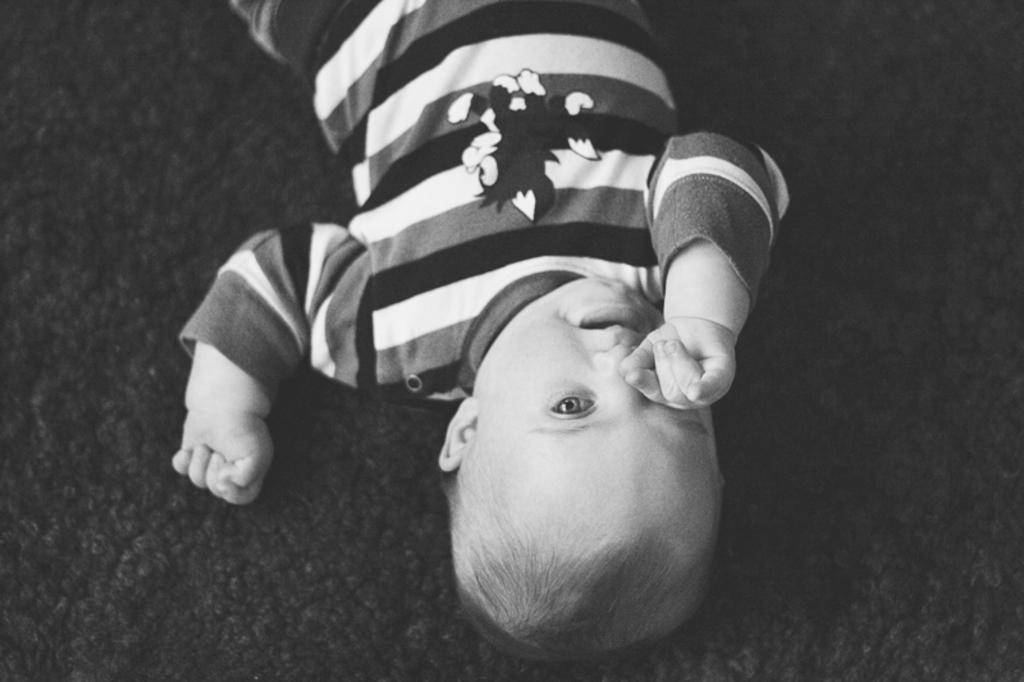What is the color scheme of the image? The image is black and white. Who is present in the image? There is a boy in the image. What is the boy doing in the image? The boy is lying on the floor. What is the boy wearing in the image? The boy is wearing a T-shirt. Can you see the boy swinging on a swing in the image? No, there is no swing or any indication of the boy swinging in the image. 